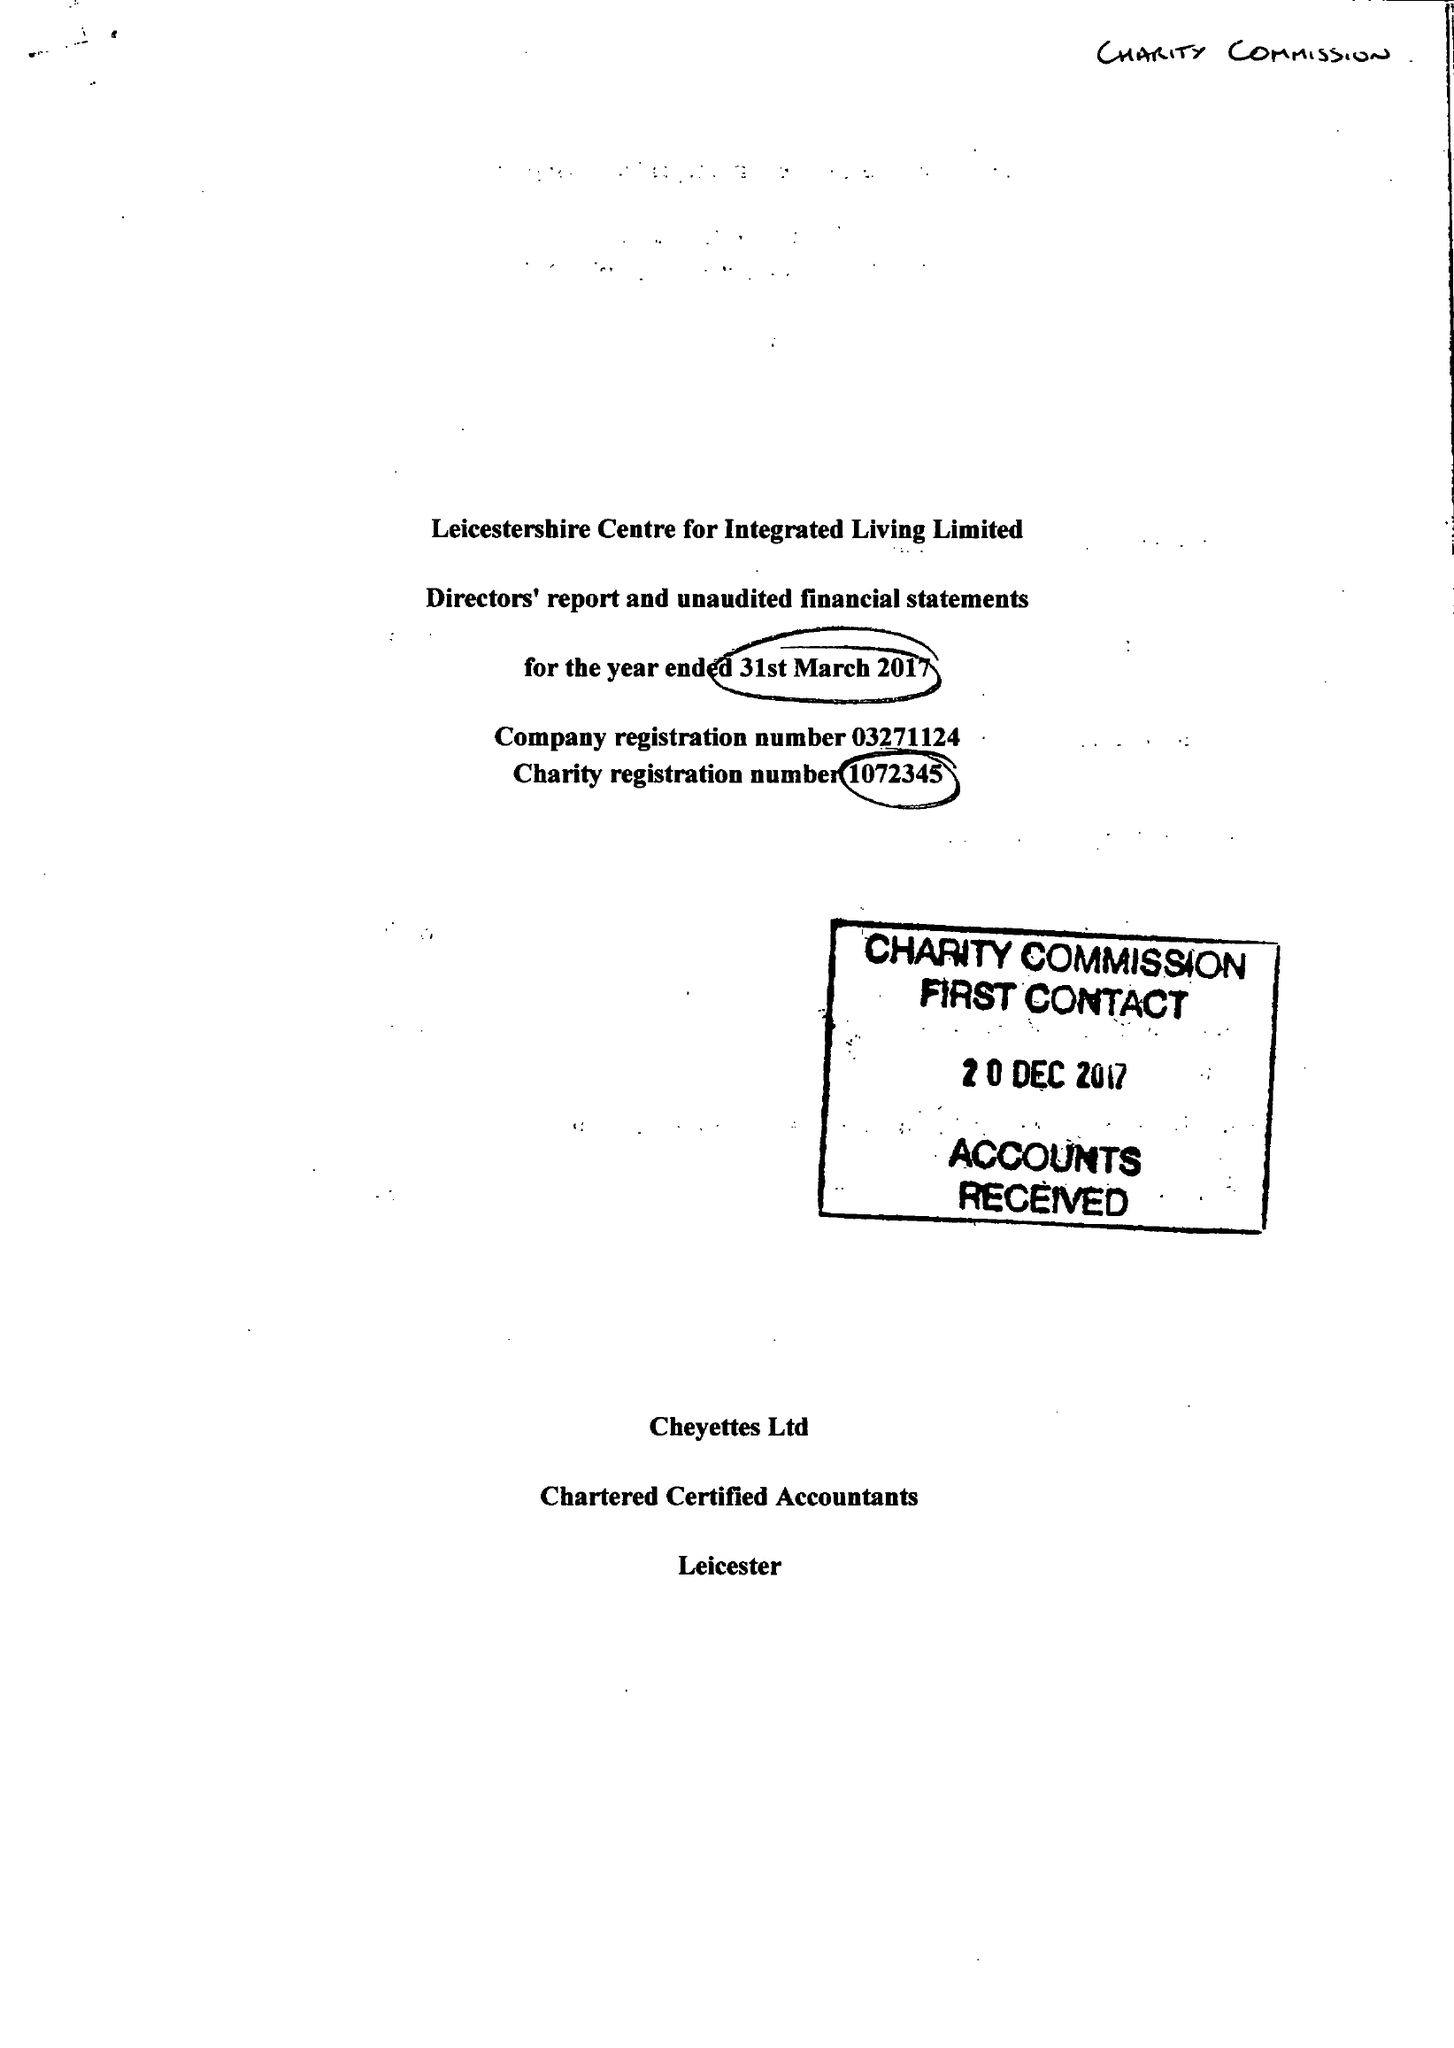What is the value for the income_annually_in_british_pounds?
Answer the question using a single word or phrase. 101578.00 